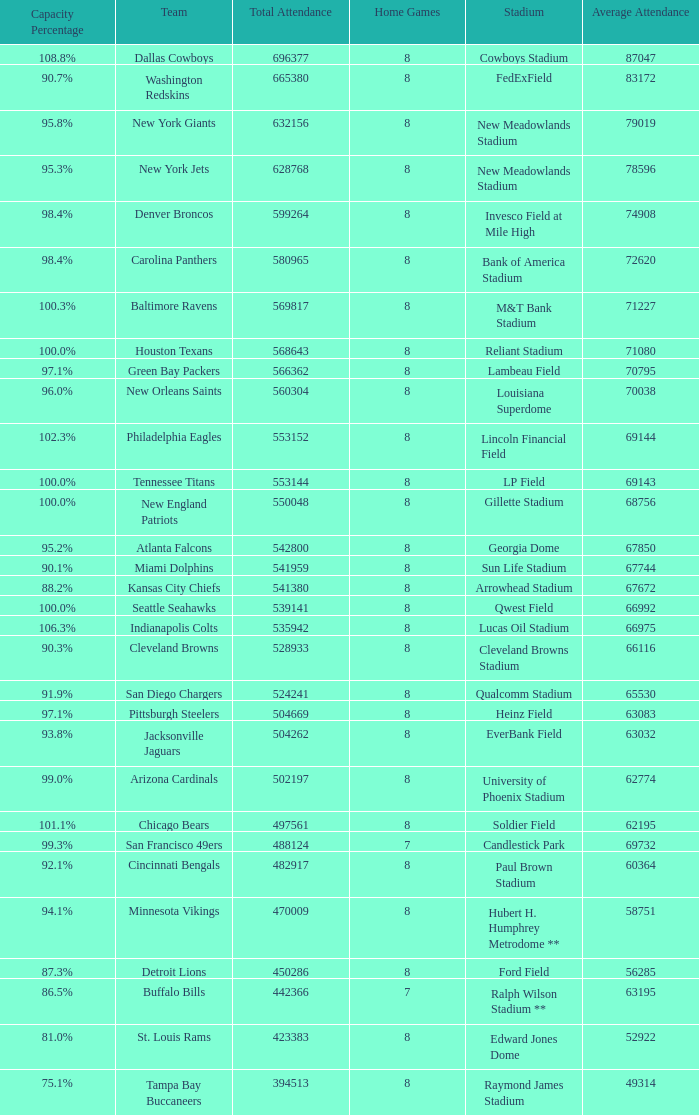Could you parse the entire table? {'header': ['Capacity Percentage', 'Team', 'Total Attendance', 'Home Games', 'Stadium', 'Average Attendance'], 'rows': [['108.8%', 'Dallas Cowboys', '696377', '8', 'Cowboys Stadium', '87047'], ['90.7%', 'Washington Redskins', '665380', '8', 'FedExField', '83172'], ['95.8%', 'New York Giants', '632156', '8', 'New Meadowlands Stadium', '79019'], ['95.3%', 'New York Jets', '628768', '8', 'New Meadowlands Stadium', '78596'], ['98.4%', 'Denver Broncos', '599264', '8', 'Invesco Field at Mile High', '74908'], ['98.4%', 'Carolina Panthers', '580965', '8', 'Bank of America Stadium', '72620'], ['100.3%', 'Baltimore Ravens', '569817', '8', 'M&T Bank Stadium', '71227'], ['100.0%', 'Houston Texans', '568643', '8', 'Reliant Stadium', '71080'], ['97.1%', 'Green Bay Packers', '566362', '8', 'Lambeau Field', '70795'], ['96.0%', 'New Orleans Saints', '560304', '8', 'Louisiana Superdome', '70038'], ['102.3%', 'Philadelphia Eagles', '553152', '8', 'Lincoln Financial Field', '69144'], ['100.0%', 'Tennessee Titans', '553144', '8', 'LP Field', '69143'], ['100.0%', 'New England Patriots', '550048', '8', 'Gillette Stadium', '68756'], ['95.2%', 'Atlanta Falcons', '542800', '8', 'Georgia Dome', '67850'], ['90.1%', 'Miami Dolphins', '541959', '8', 'Sun Life Stadium', '67744'], ['88.2%', 'Kansas City Chiefs', '541380', '8', 'Arrowhead Stadium', '67672'], ['100.0%', 'Seattle Seahawks', '539141', '8', 'Qwest Field', '66992'], ['106.3%', 'Indianapolis Colts', '535942', '8', 'Lucas Oil Stadium', '66975'], ['90.3%', 'Cleveland Browns', '528933', '8', 'Cleveland Browns Stadium', '66116'], ['91.9%', 'San Diego Chargers', '524241', '8', 'Qualcomm Stadium', '65530'], ['97.1%', 'Pittsburgh Steelers', '504669', '8', 'Heinz Field', '63083'], ['93.8%', 'Jacksonville Jaguars', '504262', '8', 'EverBank Field', '63032'], ['99.0%', 'Arizona Cardinals', '502197', '8', 'University of Phoenix Stadium', '62774'], ['101.1%', 'Chicago Bears', '497561', '8', 'Soldier Field', '62195'], ['99.3%', 'San Francisco 49ers', '488124', '7', 'Candlestick Park', '69732'], ['92.1%', 'Cincinnati Bengals', '482917', '8', 'Paul Brown Stadium', '60364'], ['94.1%', 'Minnesota Vikings', '470009', '8', 'Hubert H. Humphrey Metrodome **', '58751'], ['87.3%', 'Detroit Lions', '450286', '8', 'Ford Field', '56285'], ['86.5%', 'Buffalo Bills', '442366', '7', 'Ralph Wilson Stadium **', '63195'], ['81.0%', 'St. Louis Rams', '423383', '8', 'Edward Jones Dome', '52922'], ['75.1%', 'Tampa Bay Buccaneers', '394513', '8', 'Raymond James Stadium', '49314']]} What was the total attendance of the New York Giants? 632156.0. 